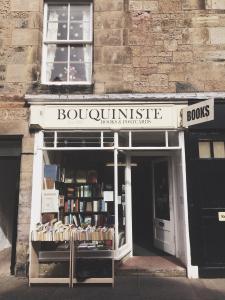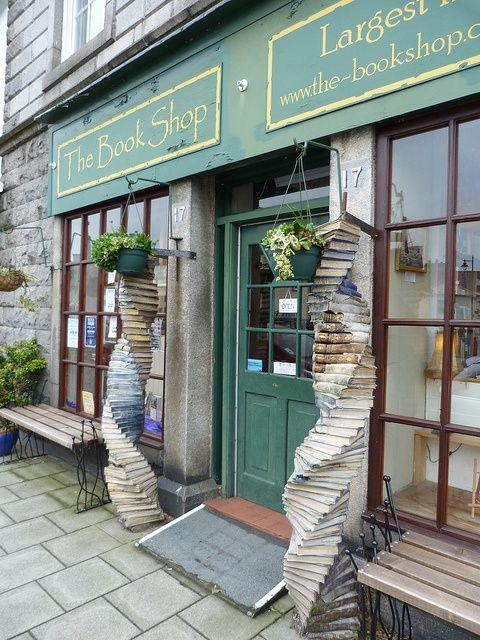The first image is the image on the left, the second image is the image on the right. For the images displayed, is the sentence "Atleast one door is brown" factually correct? Answer yes or no. No. The first image is the image on the left, the second image is the image on the right. Evaluate the accuracy of this statement regarding the images: "A bookstore exterior has lattice above big display windows, a shield shape over paned glass, and a statue of a figure inset in an arch on the building's front.". Is it true? Answer yes or no. No. 